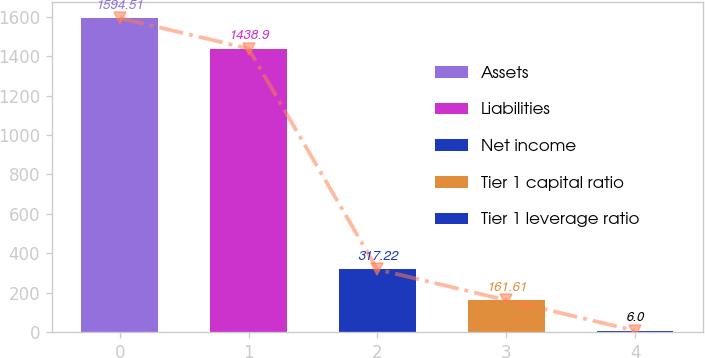Convert chart. <chart><loc_0><loc_0><loc_500><loc_500><bar_chart><fcel>Assets<fcel>Liabilities<fcel>Net income<fcel>Tier 1 capital ratio<fcel>Tier 1 leverage ratio<nl><fcel>1594.51<fcel>1438.9<fcel>317.22<fcel>161.61<fcel>6<nl></chart> 